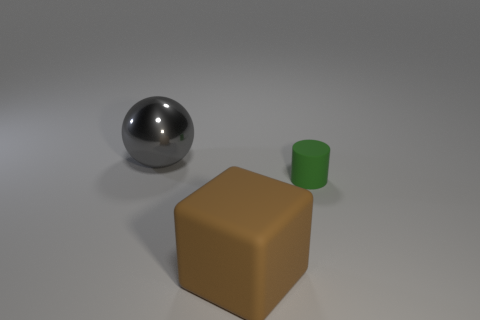Add 1 red objects. How many objects exist? 4 Subtract 0 gray cylinders. How many objects are left? 3 Subtract all cylinders. How many objects are left? 2 Subtract 1 spheres. How many spheres are left? 0 Subtract all matte cylinders. Subtract all gray shiny balls. How many objects are left? 1 Add 2 large brown blocks. How many large brown blocks are left? 3 Add 2 tiny green things. How many tiny green things exist? 3 